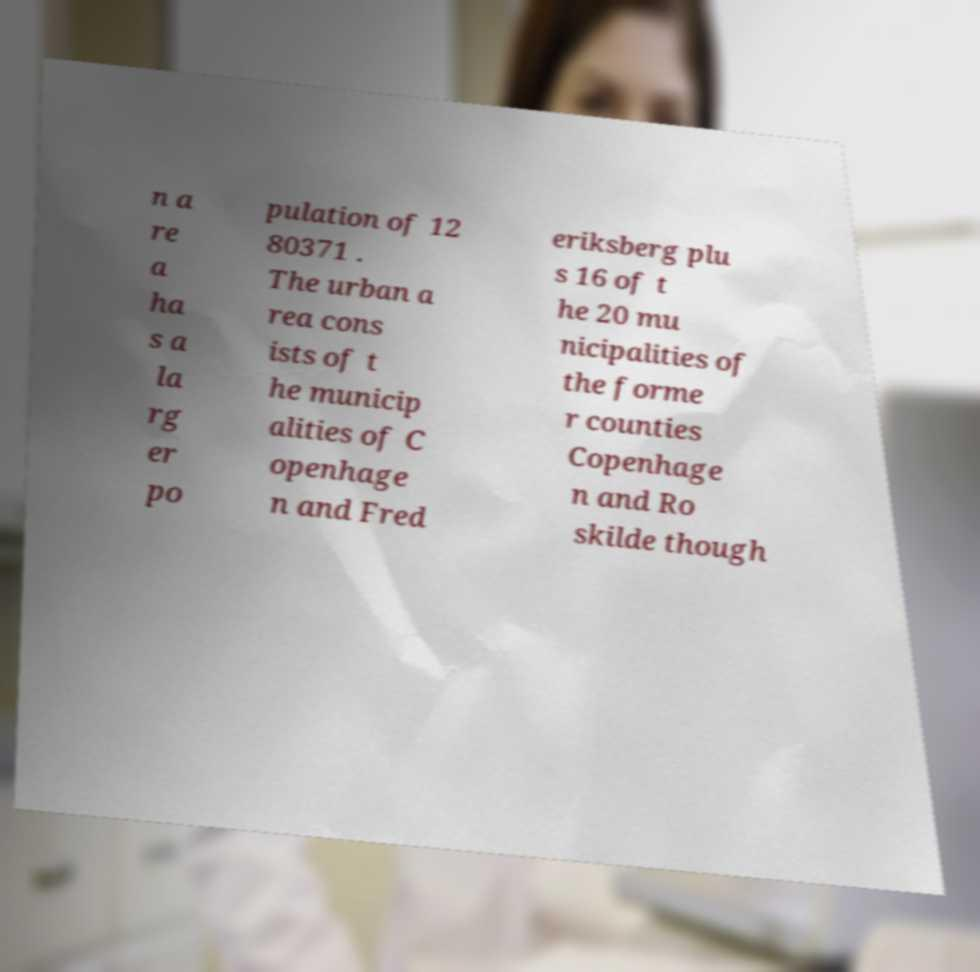For documentation purposes, I need the text within this image transcribed. Could you provide that? n a re a ha s a la rg er po pulation of 12 80371 . The urban a rea cons ists of t he municip alities of C openhage n and Fred eriksberg plu s 16 of t he 20 mu nicipalities of the forme r counties Copenhage n and Ro skilde though 